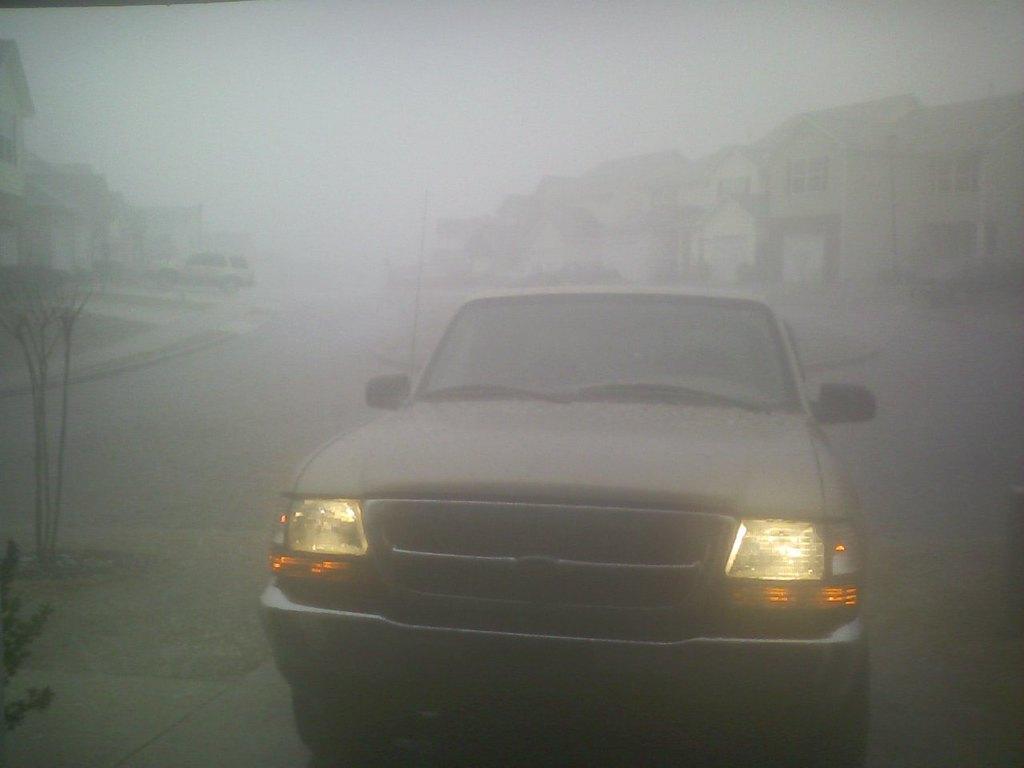In one or two sentences, can you explain what this image depicts? In this picture we can see a car on the road and in the background we can see a vehicle, buildings and the sky. 